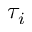Convert formula to latex. <formula><loc_0><loc_0><loc_500><loc_500>\tau _ { i }</formula> 